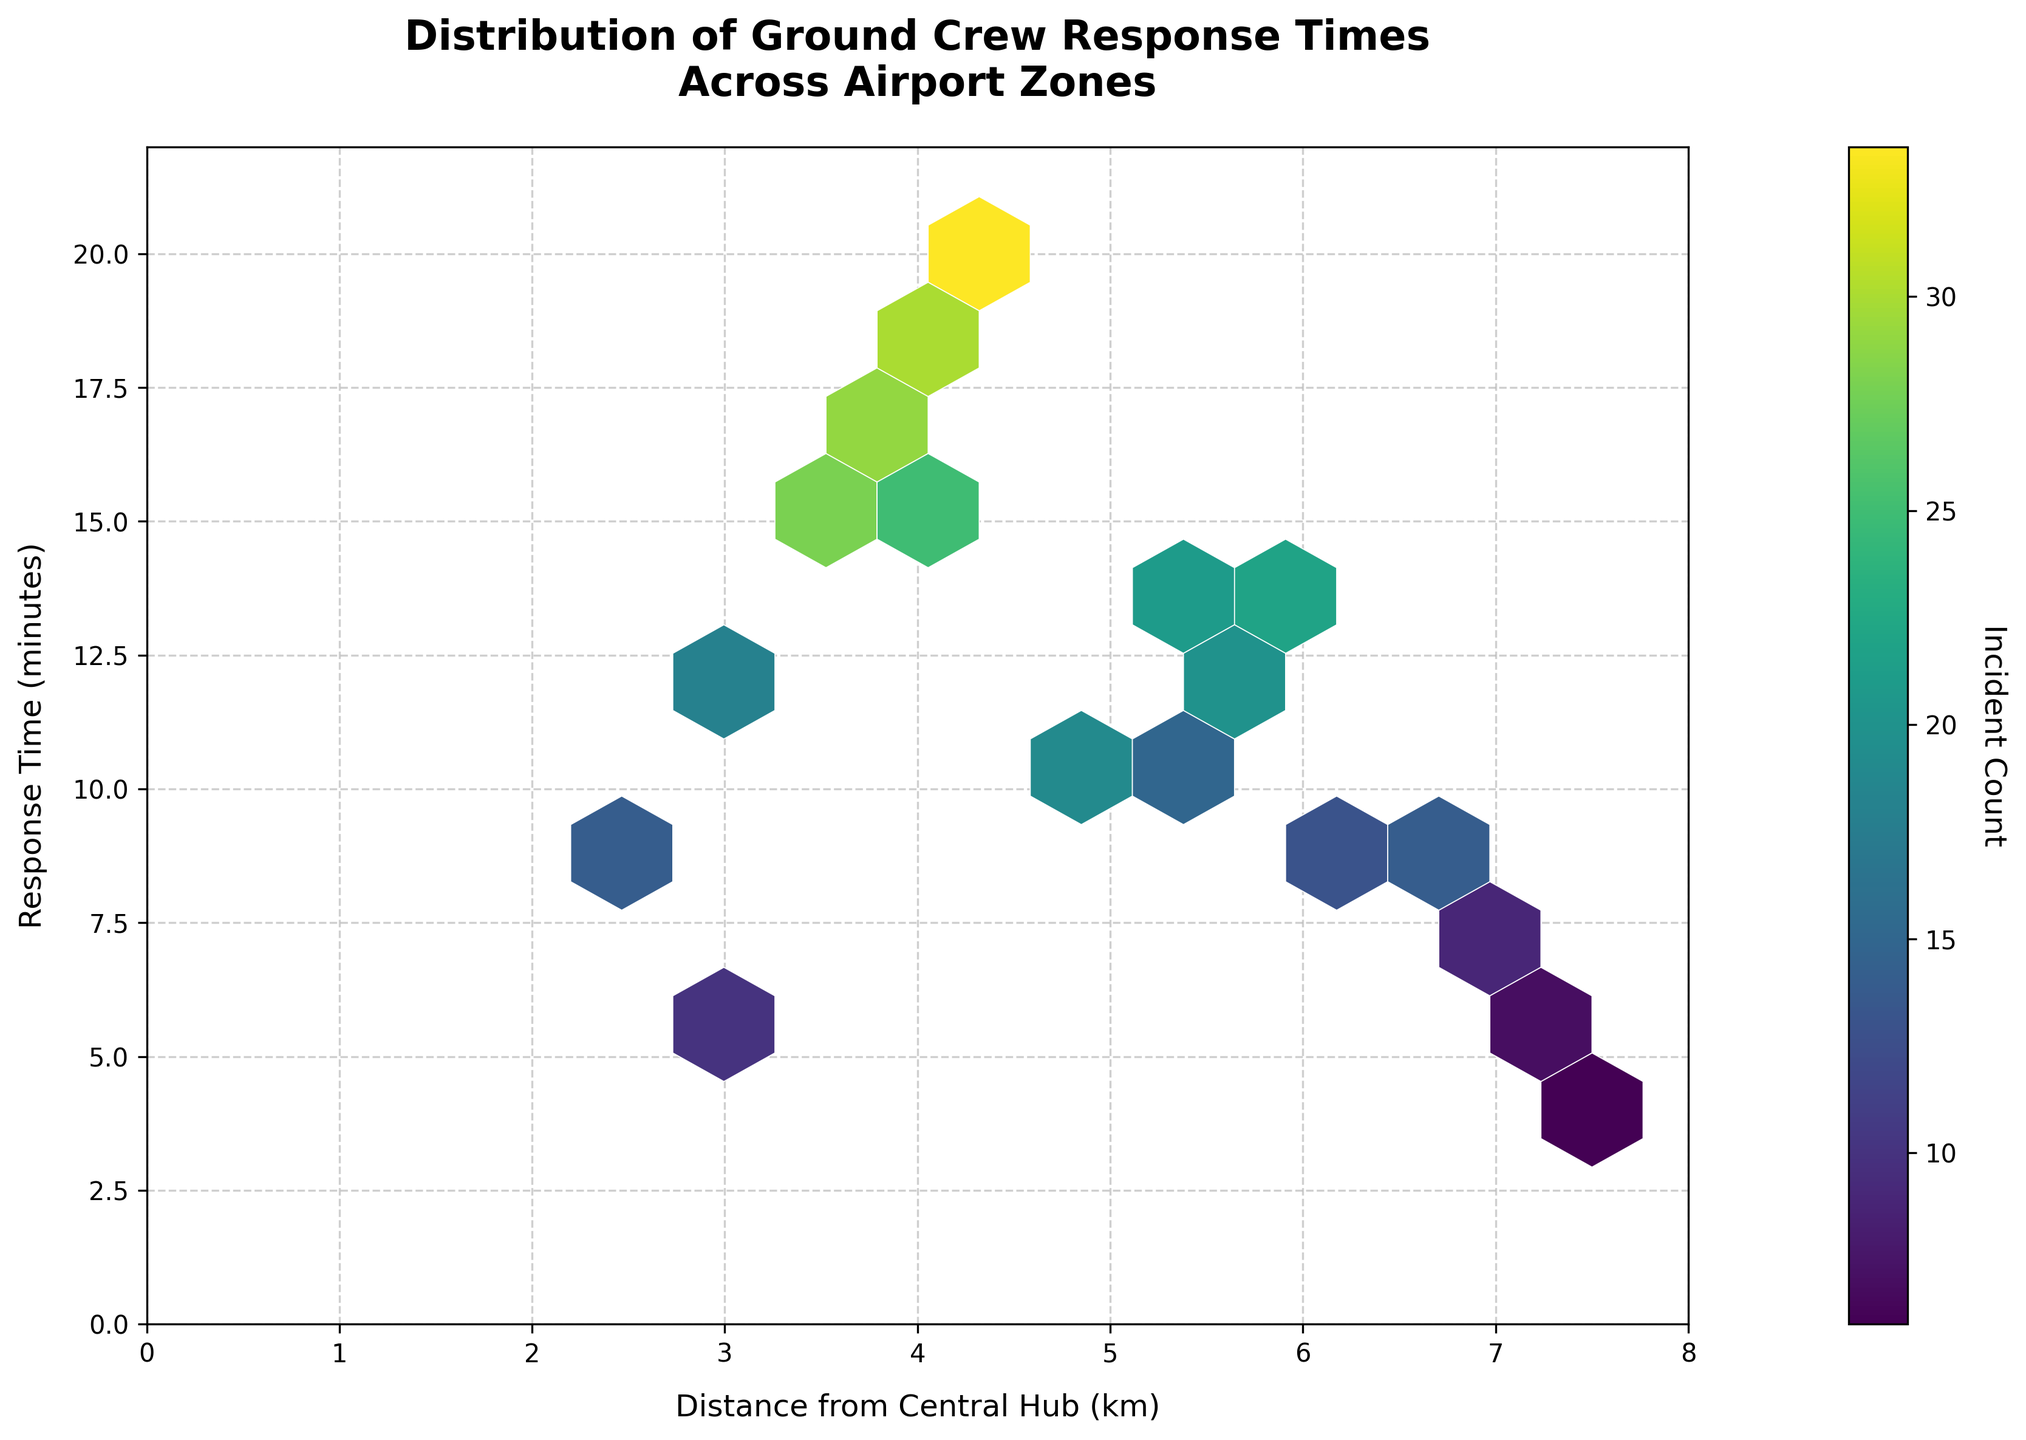What is the title of the hexbin plot? The title is located at the top of the plot and reads 'Distribution of Ground Crew Response Times Across Airport Zones'.
Answer: Distribution of Ground Crew Response Times Across Airport Zones What do the x and y axes represent in this plot? The x-axis label is 'Distance from Central Hub (km)' indicating the distance in kilometers, and the y-axis label is 'Response Time (minutes)' indicating the response time in minutes.
Answer: Distance from Central Hub (km) and Response Time (minutes) What does the color of the hexagons represent in this plot? The color of the hexagons represents the 'Incident Count', which is indicated by the color bar to the right of the plot ranging from lighter to darker shades.
Answer: Incident Count Which zone shows the highest response time and also has a high incident count? Observing the plot, the hexagon at (4.5, 20) has a high response time of 20 minutes and a high incident count, indicated by a darker shade.
Answer: (4.5, 20) What is the approximate range of distances where the incident count is highest? The incidents count appears to be highest in the range of distances from approximately 3 km to 5 km from the central hub, as indicated by the darker hexagons within this range on the x-axis.
Answer: 3 km to 5 km Which hexagon has the highest reported incident count? Observing the color intensity, the hexagon around coordinates (4.5, 20) has the darkest shade, indicating the highest incident count.
Answer: (4.5, 20) Do zones closer to the central hub generally have shorter response times? Yes, generally the hexagons closer to the central hub (lower x values) have shorter response times as indicated by hexagons clustered around the lower values on the y-axis.
Answer: Yes In which distance range do we observe the shortest response times? The shortest response times seem to be clustered around distances from approximately 2 to 3 km from the central hub, indicated by lighter and smaller y values in this range.
Answer: 2 to 3 km What is the response time at the 6.5 km distance from the central hub? For the 6.5 km distance from the central hub, the response time appears to be around 9 minutes as indicated by the hexagon's y coordinate.
Answer: 9 minutes 